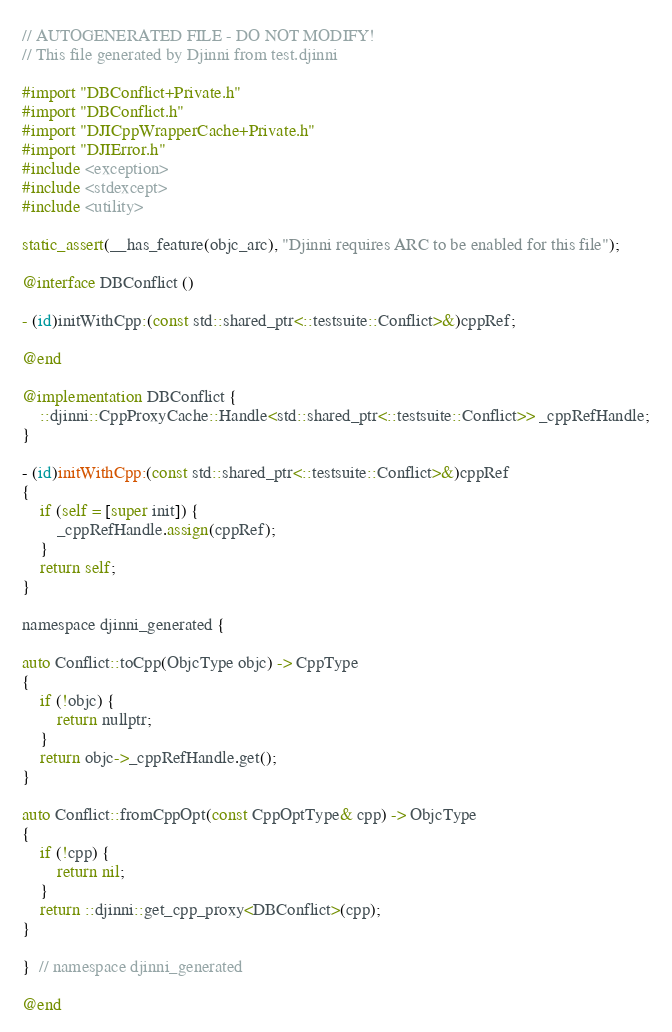Convert code to text. <code><loc_0><loc_0><loc_500><loc_500><_ObjectiveC_>// AUTOGENERATED FILE - DO NOT MODIFY!
// This file generated by Djinni from test.djinni

#import "DBConflict+Private.h"
#import "DBConflict.h"
#import "DJICppWrapperCache+Private.h"
#import "DJIError.h"
#include <exception>
#include <stdexcept>
#include <utility>

static_assert(__has_feature(objc_arc), "Djinni requires ARC to be enabled for this file");

@interface DBConflict ()

- (id)initWithCpp:(const std::shared_ptr<::testsuite::Conflict>&)cppRef;

@end

@implementation DBConflict {
    ::djinni::CppProxyCache::Handle<std::shared_ptr<::testsuite::Conflict>> _cppRefHandle;
}

- (id)initWithCpp:(const std::shared_ptr<::testsuite::Conflict>&)cppRef
{
    if (self = [super init]) {
        _cppRefHandle.assign(cppRef);
    }
    return self;
}

namespace djinni_generated {

auto Conflict::toCpp(ObjcType objc) -> CppType
{
    if (!objc) {
        return nullptr;
    }
    return objc->_cppRefHandle.get();
}

auto Conflict::fromCppOpt(const CppOptType& cpp) -> ObjcType
{
    if (!cpp) {
        return nil;
    }
    return ::djinni::get_cpp_proxy<DBConflict>(cpp);
}

}  // namespace djinni_generated

@end
</code> 